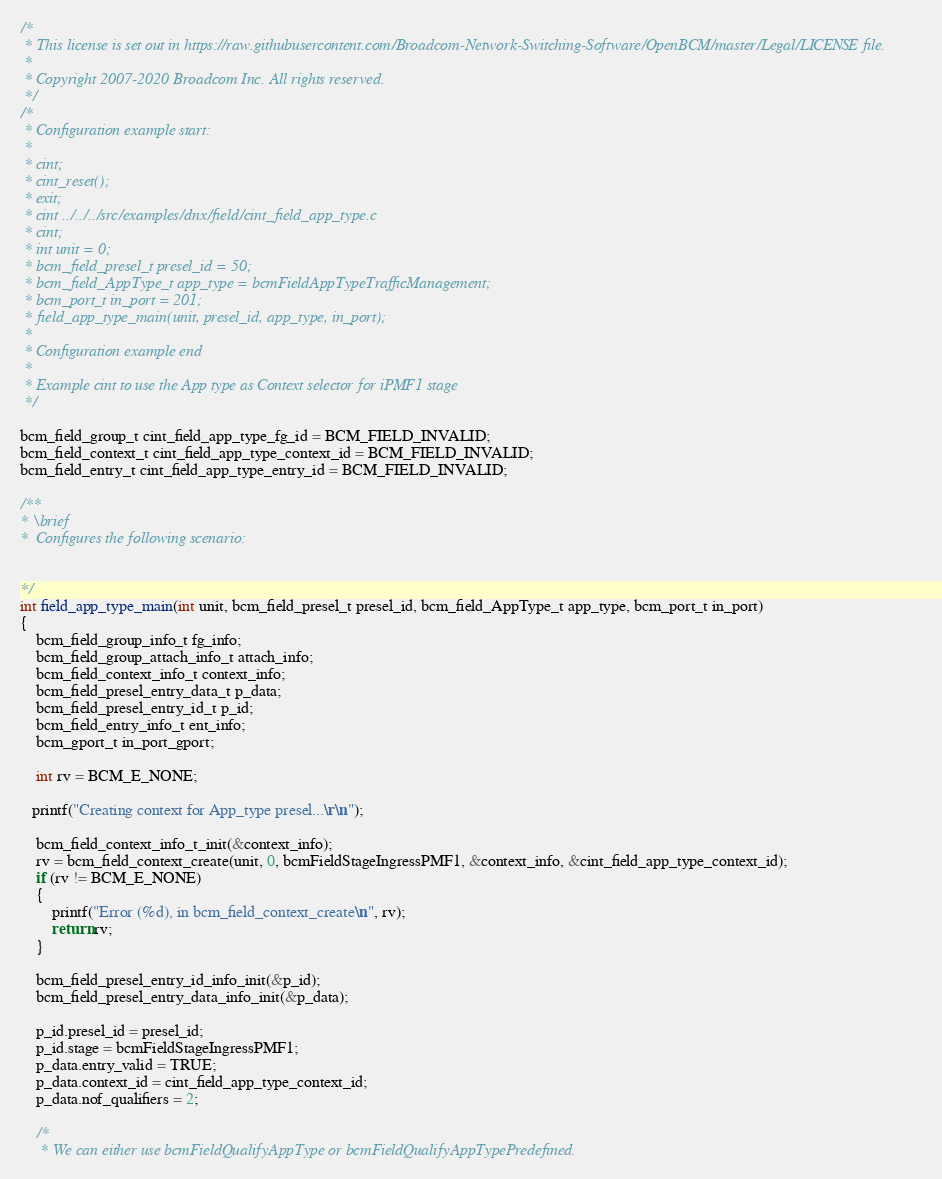<code> <loc_0><loc_0><loc_500><loc_500><_C_>/*
 * This license is set out in https://raw.githubusercontent.com/Broadcom-Network-Switching-Software/OpenBCM/master/Legal/LICENSE file.
 * 
 * Copyright 2007-2020 Broadcom Inc. All rights reserved.
 */
/*
 * Configuration example start:
 *
 * cint;
 * cint_reset();
 * exit;
 * cint ../../../src/examples/dnx/field/cint_field_app_type.c
 * cint;
 * int unit = 0;
 * bcm_field_presel_t presel_id = 50;
 * bcm_field_AppType_t app_type = bcmFieldAppTypeTrafficManagement;
 * bcm_port_t in_port = 201;
 * field_app_type_main(unit, presel_id, app_type, in_port);
 *
 * Configuration example end
 *
 * Example cint to use the App type as Context selector for iPMF1 stage
 */

bcm_field_group_t cint_field_app_type_fg_id = BCM_FIELD_INVALID;
bcm_field_context_t cint_field_app_type_context_id = BCM_FIELD_INVALID;
bcm_field_entry_t cint_field_app_type_entry_id = BCM_FIELD_INVALID;

/**
* \brief
*  Configures the following scenario:


*/
int field_app_type_main(int unit, bcm_field_presel_t presel_id, bcm_field_AppType_t app_type, bcm_port_t in_port)
{
    bcm_field_group_info_t fg_info;
    bcm_field_group_attach_info_t attach_info;
    bcm_field_context_info_t context_info;
    bcm_field_presel_entry_data_t p_data;    
    bcm_field_presel_entry_id_t p_id;
    bcm_field_entry_info_t ent_info;
    bcm_gport_t in_port_gport;

    int rv = BCM_E_NONE;

   printf("Creating context for App_type presel...\r\n");

    bcm_field_context_info_t_init(&context_info);
    rv = bcm_field_context_create(unit, 0, bcmFieldStageIngressPMF1, &context_info, &cint_field_app_type_context_id);
    if (rv != BCM_E_NONE)
    {
        printf("Error (%d), in bcm_field_context_create\n", rv);
        return rv;
    }

    bcm_field_presel_entry_id_info_init(&p_id);
    bcm_field_presel_entry_data_info_init(&p_data);
    
    p_id.presel_id = presel_id;
    p_id.stage = bcmFieldStageIngressPMF1;
    p_data.entry_valid = TRUE;
    p_data.context_id = cint_field_app_type_context_id;
    p_data.nof_qualifiers = 2;

    /*
     * We can either use bcmFieldQualifyAppType or bcmFieldQualifyAppTypePredefined. </code> 